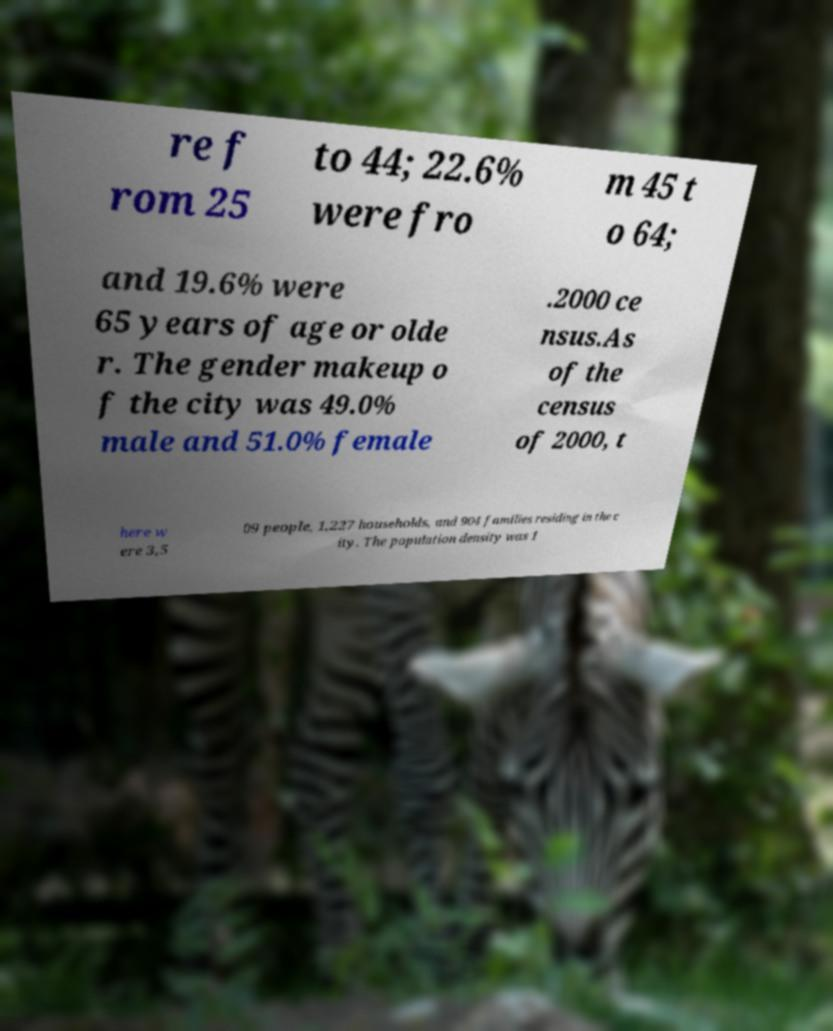Please identify and transcribe the text found in this image. re f rom 25 to 44; 22.6% were fro m 45 t o 64; and 19.6% were 65 years of age or olde r. The gender makeup o f the city was 49.0% male and 51.0% female .2000 ce nsus.As of the census of 2000, t here w ere 3,5 09 people, 1,227 households, and 904 families residing in the c ity. The population density was 1 